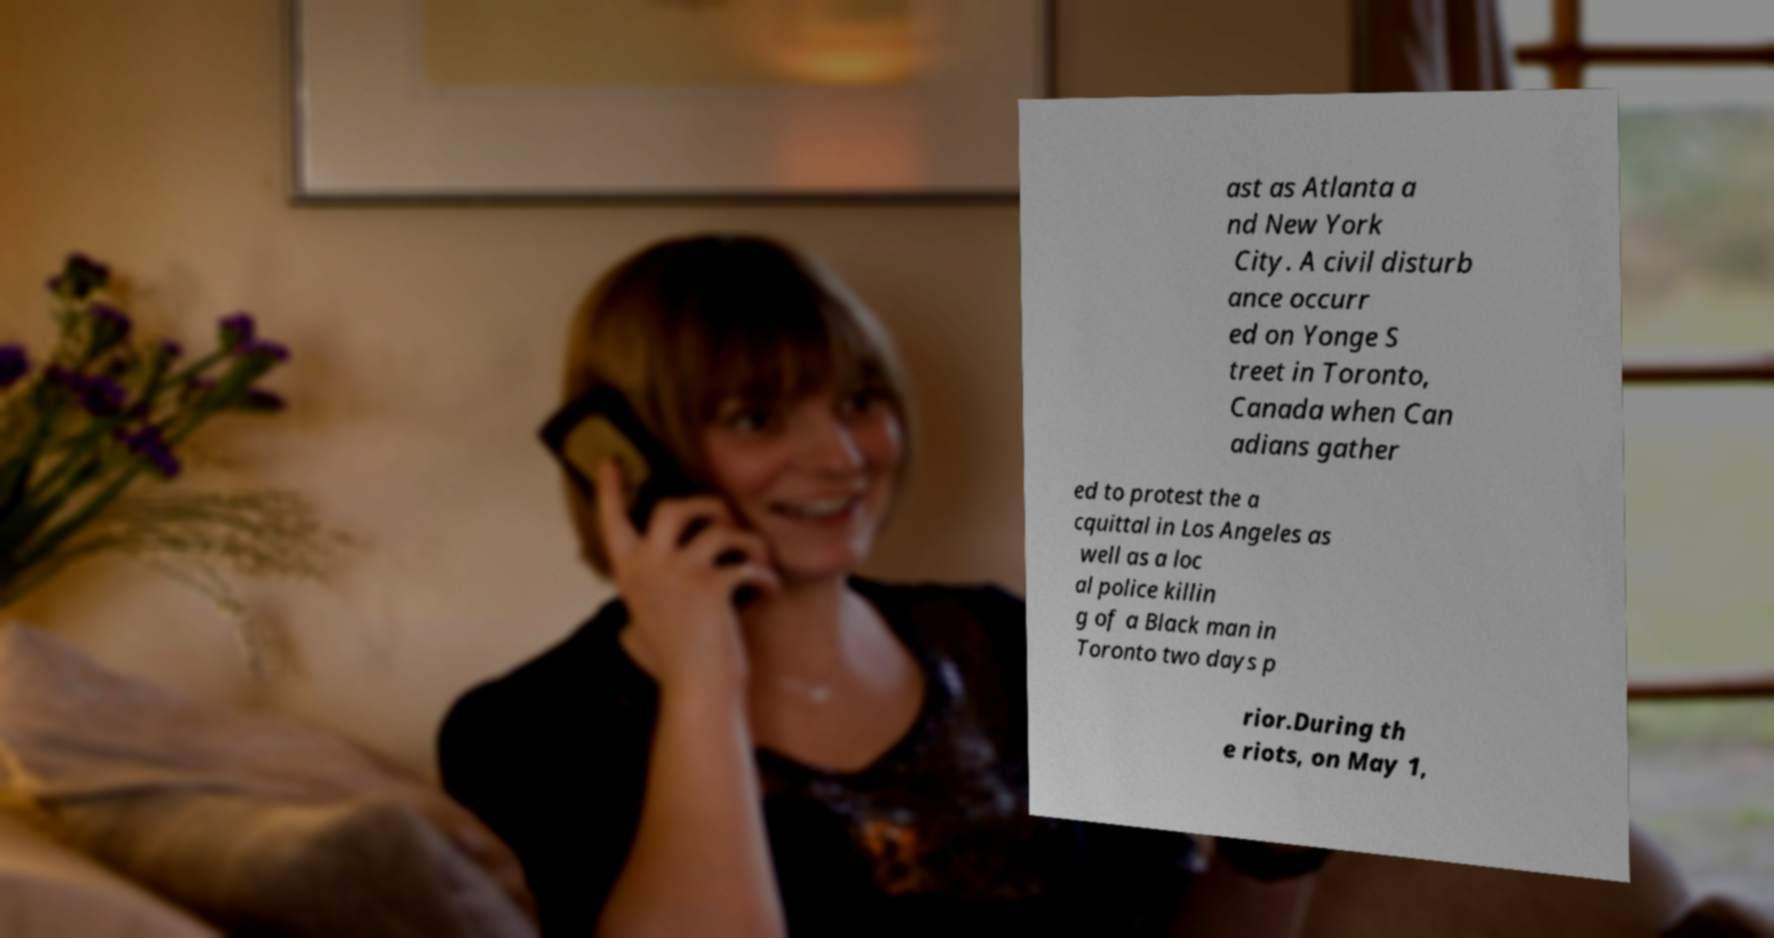Can you read and provide the text displayed in the image?This photo seems to have some interesting text. Can you extract and type it out for me? ast as Atlanta a nd New York City. A civil disturb ance occurr ed on Yonge S treet in Toronto, Canada when Can adians gather ed to protest the a cquittal in Los Angeles as well as a loc al police killin g of a Black man in Toronto two days p rior.During th e riots, on May 1, 